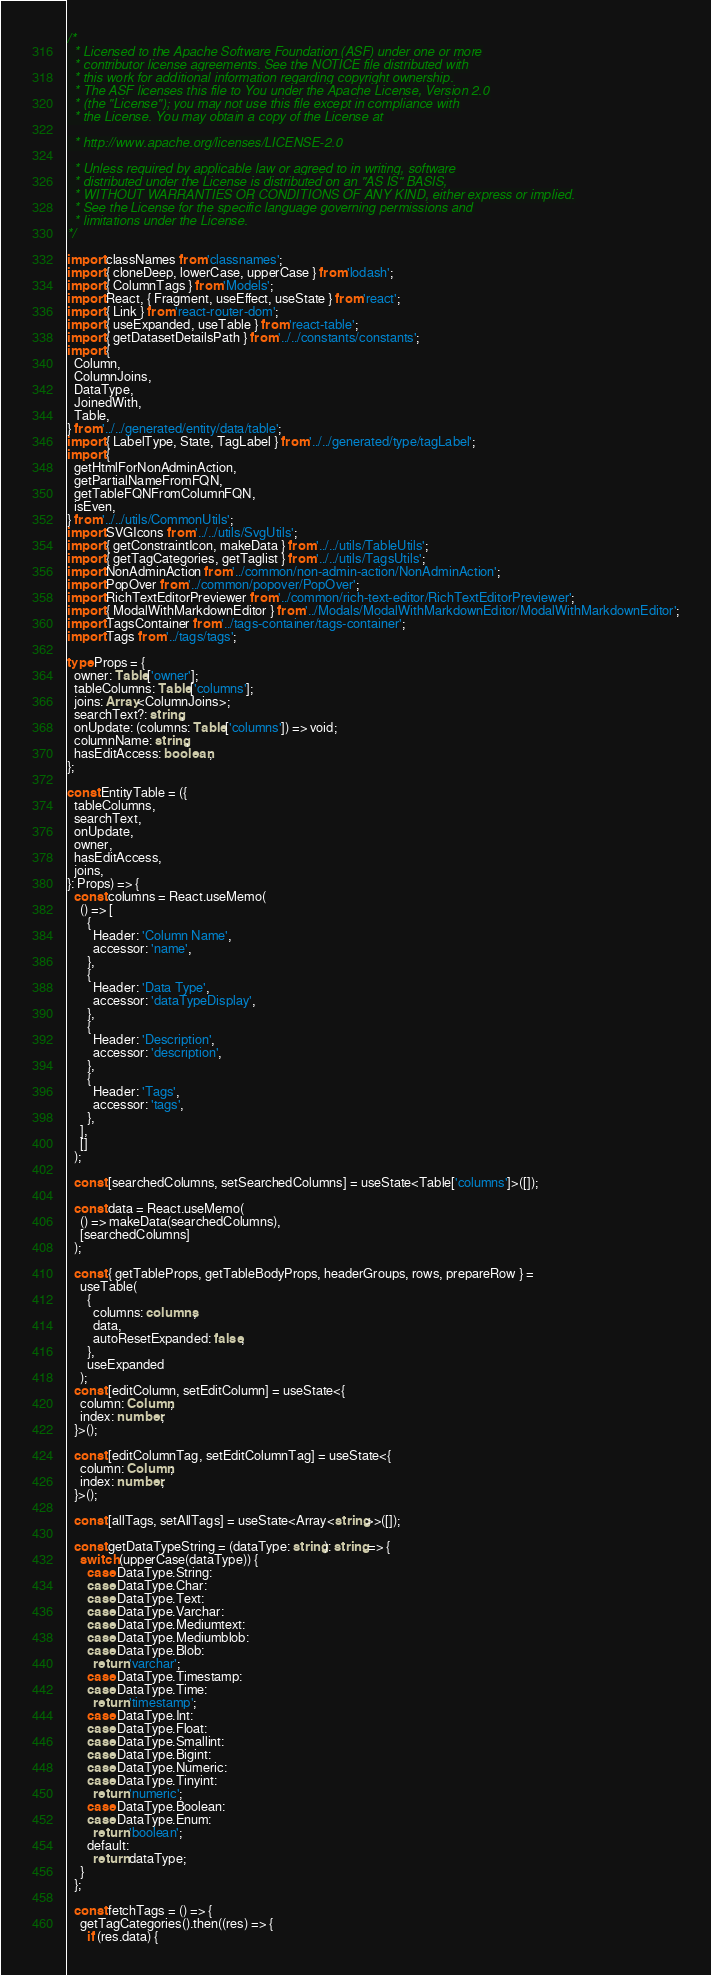Convert code to text. <code><loc_0><loc_0><loc_500><loc_500><_TypeScript_>/*
  * Licensed to the Apache Software Foundation (ASF) under one or more
  * contributor license agreements. See the NOTICE file distributed with
  * this work for additional information regarding copyright ownership.
  * The ASF licenses this file to You under the Apache License, Version 2.0
  * (the "License"); you may not use this file except in compliance with
  * the License. You may obtain a copy of the License at

  * http://www.apache.org/licenses/LICENSE-2.0

  * Unless required by applicable law or agreed to in writing, software
  * distributed under the License is distributed on an "AS IS" BASIS,
  * WITHOUT WARRANTIES OR CONDITIONS OF ANY KIND, either express or implied.
  * See the License for the specific language governing permissions and
  * limitations under the License.
*/

import classNames from 'classnames';
import { cloneDeep, lowerCase, upperCase } from 'lodash';
import { ColumnTags } from 'Models';
import React, { Fragment, useEffect, useState } from 'react';
import { Link } from 'react-router-dom';
import { useExpanded, useTable } from 'react-table';
import { getDatasetDetailsPath } from '../../constants/constants';
import {
  Column,
  ColumnJoins,
  DataType,
  JoinedWith,
  Table,
} from '../../generated/entity/data/table';
import { LabelType, State, TagLabel } from '../../generated/type/tagLabel';
import {
  getHtmlForNonAdminAction,
  getPartialNameFromFQN,
  getTableFQNFromColumnFQN,
  isEven,
} from '../../utils/CommonUtils';
import SVGIcons from '../../utils/SvgUtils';
import { getConstraintIcon, makeData } from '../../utils/TableUtils';
import { getTagCategories, getTaglist } from '../../utils/TagsUtils';
import NonAdminAction from '../common/non-admin-action/NonAdminAction';
import PopOver from '../common/popover/PopOver';
import RichTextEditorPreviewer from '../common/rich-text-editor/RichTextEditorPreviewer';
import { ModalWithMarkdownEditor } from '../Modals/ModalWithMarkdownEditor/ModalWithMarkdownEditor';
import TagsContainer from '../tags-container/tags-container';
import Tags from '../tags/tags';

type Props = {
  owner: Table['owner'];
  tableColumns: Table['columns'];
  joins: Array<ColumnJoins>;
  searchText?: string;
  onUpdate: (columns: Table['columns']) => void;
  columnName: string;
  hasEditAccess: boolean;
};

const EntityTable = ({
  tableColumns,
  searchText,
  onUpdate,
  owner,
  hasEditAccess,
  joins,
}: Props) => {
  const columns = React.useMemo(
    () => [
      {
        Header: 'Column Name',
        accessor: 'name',
      },
      {
        Header: 'Data Type',
        accessor: 'dataTypeDisplay',
      },
      {
        Header: 'Description',
        accessor: 'description',
      },
      {
        Header: 'Tags',
        accessor: 'tags',
      },
    ],
    []
  );

  const [searchedColumns, setSearchedColumns] = useState<Table['columns']>([]);

  const data = React.useMemo(
    () => makeData(searchedColumns),
    [searchedColumns]
  );

  const { getTableProps, getTableBodyProps, headerGroups, rows, prepareRow } =
    useTable(
      {
        columns: columns,
        data,
        autoResetExpanded: false,
      },
      useExpanded
    );
  const [editColumn, setEditColumn] = useState<{
    column: Column;
    index: number;
  }>();

  const [editColumnTag, setEditColumnTag] = useState<{
    column: Column;
    index: number;
  }>();

  const [allTags, setAllTags] = useState<Array<string>>([]);

  const getDataTypeString = (dataType: string): string => {
    switch (upperCase(dataType)) {
      case DataType.String:
      case DataType.Char:
      case DataType.Text:
      case DataType.Varchar:
      case DataType.Mediumtext:
      case DataType.Mediumblob:
      case DataType.Blob:
        return 'varchar';
      case DataType.Timestamp:
      case DataType.Time:
        return 'timestamp';
      case DataType.Int:
      case DataType.Float:
      case DataType.Smallint:
      case DataType.Bigint:
      case DataType.Numeric:
      case DataType.Tinyint:
        return 'numeric';
      case DataType.Boolean:
      case DataType.Enum:
        return 'boolean';
      default:
        return dataType;
    }
  };

  const fetchTags = () => {
    getTagCategories().then((res) => {
      if (res.data) {</code> 